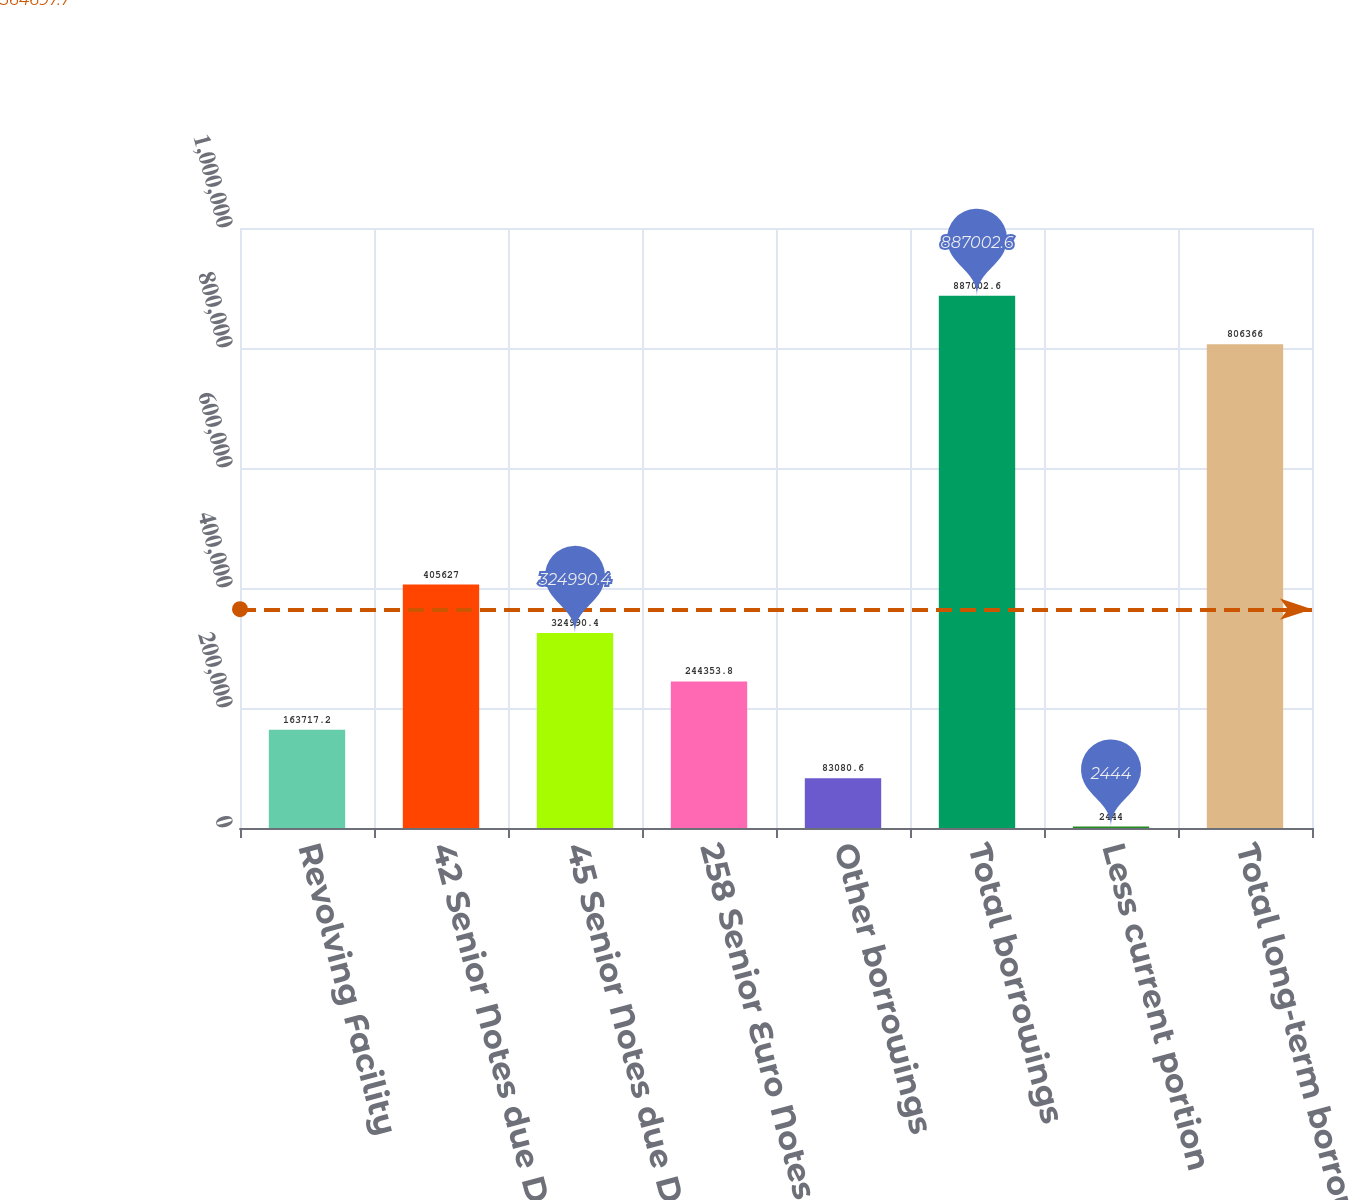Convert chart. <chart><loc_0><loc_0><loc_500><loc_500><bar_chart><fcel>Revolving Facility<fcel>42 Senior Notes due December<fcel>45 Senior Notes due December<fcel>258 Senior Euro Notes due June<fcel>Other borrowings<fcel>Total borrowings<fcel>Less current portion<fcel>Total long-term borrowings<nl><fcel>163717<fcel>405627<fcel>324990<fcel>244354<fcel>83080.6<fcel>887003<fcel>2444<fcel>806366<nl></chart> 